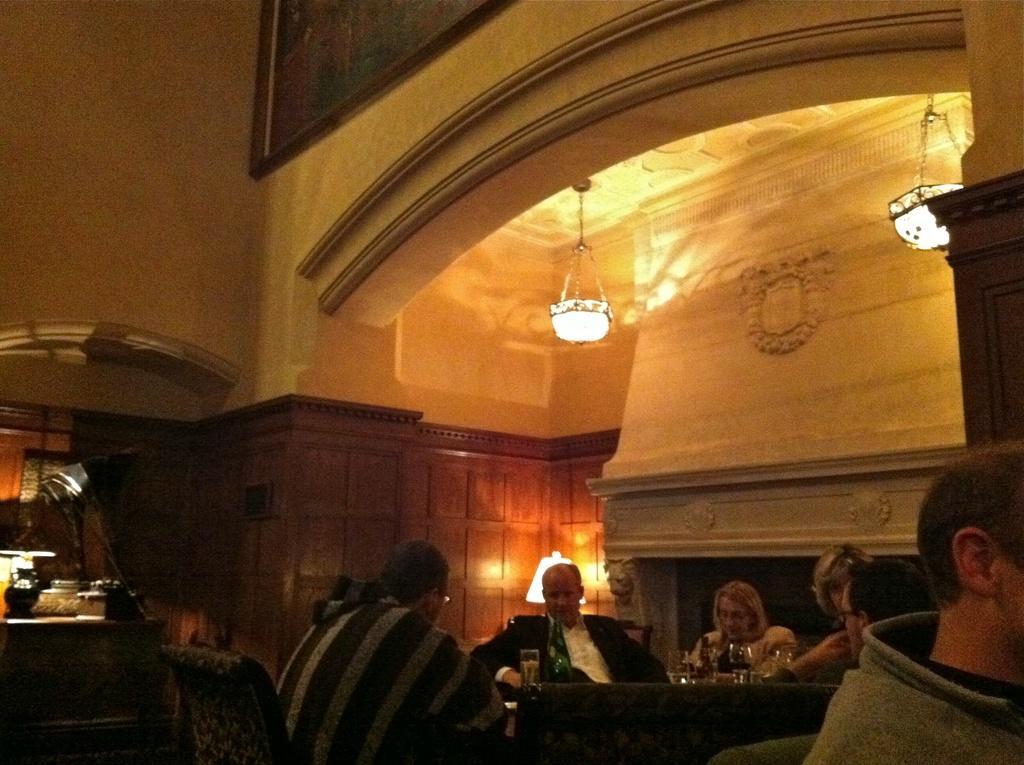Could you give a brief overview of what you see in this image? In this image we can see few people sitting on chairs. There are glasses and some other items on the table. In the back there is a wall and arch. On the wall there is a photo frame. Also there are lights. On the left side there is a table. On that there are some items. 